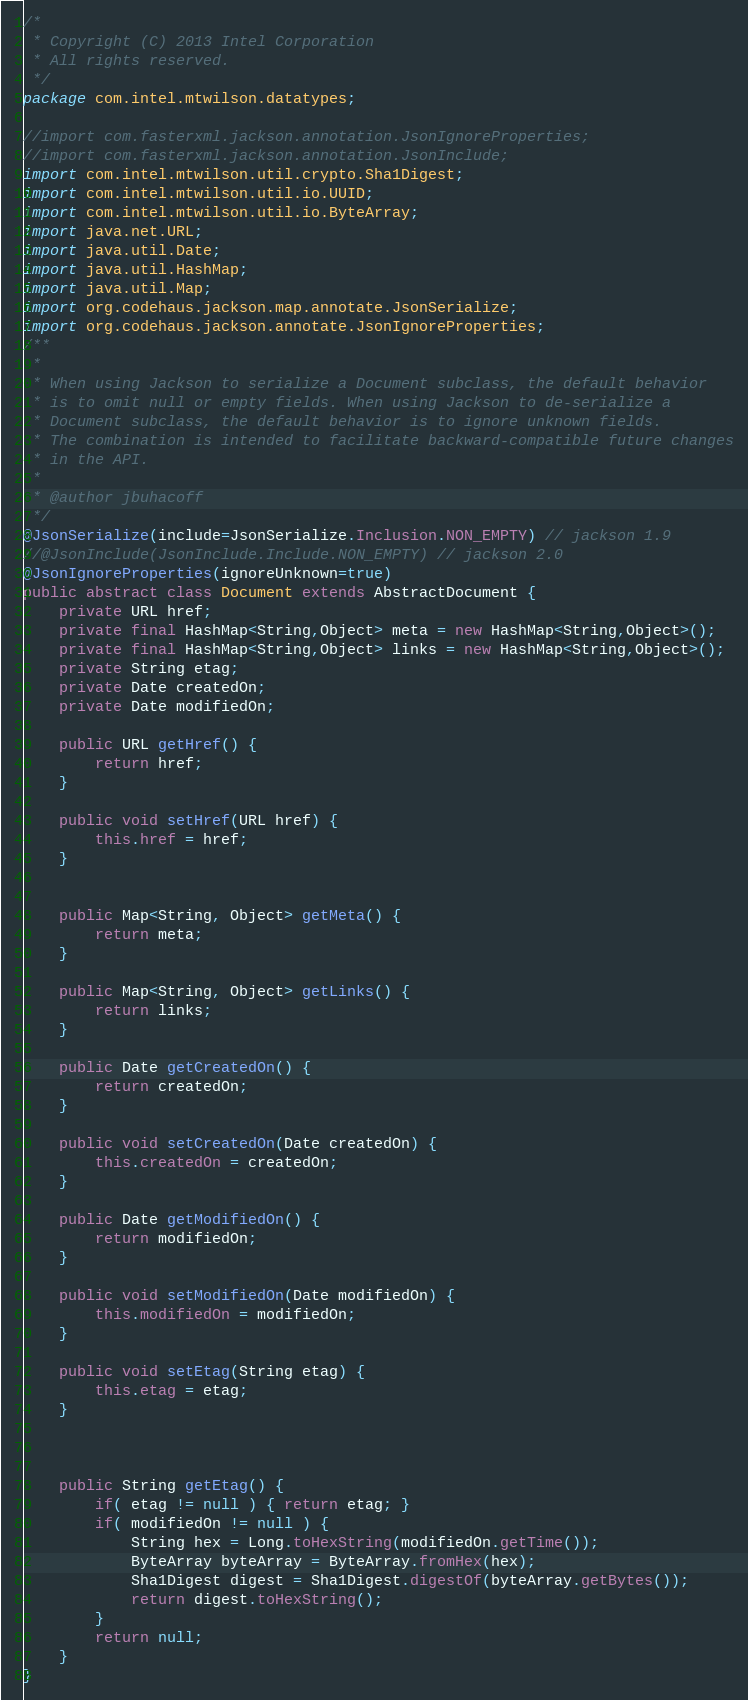Convert code to text. <code><loc_0><loc_0><loc_500><loc_500><_Java_>/*
 * Copyright (C) 2013 Intel Corporation
 * All rights reserved.
 */
package com.intel.mtwilson.datatypes;

//import com.fasterxml.jackson.annotation.JsonIgnoreProperties;
//import com.fasterxml.jackson.annotation.JsonInclude;
import com.intel.mtwilson.util.crypto.Sha1Digest;
import com.intel.mtwilson.util.io.UUID;
import com.intel.mtwilson.util.io.ByteArray;
import java.net.URL;
import java.util.Date;
import java.util.HashMap;
import java.util.Map;
import org.codehaus.jackson.map.annotate.JsonSerialize;
import org.codehaus.jackson.annotate.JsonIgnoreProperties;
/**
 *
 * When using Jackson to serialize a Document subclass, the default behavior
 * is to omit null or empty fields. When using Jackson to de-serialize a
 * Document subclass, the default behavior is to ignore unknown fields. 
 * The combination is intended to facilitate backward-compatible future changes
 * in the API.
 * 
 * @author jbuhacoff
 */
@JsonSerialize(include=JsonSerialize.Inclusion.NON_EMPTY) // jackson 1.9
//@JsonInclude(JsonInclude.Include.NON_EMPTY) // jackson 2.0
@JsonIgnoreProperties(ignoreUnknown=true)
public abstract class Document extends AbstractDocument {
    private URL href;
    private final HashMap<String,Object> meta = new HashMap<String,Object>();
    private final HashMap<String,Object> links = new HashMap<String,Object>();
    private String etag;
    private Date createdOn; 
    private Date modifiedOn;
    
    public URL getHref() {
        return href;
    }
    
    public void setHref(URL href) {
        this.href = href;
    }
    
    
    public Map<String, Object> getMeta() {
        return meta;
    }

    public Map<String, Object> getLinks() {
        return links;
    }

    public Date getCreatedOn() {
        return createdOn;
    }

    public void setCreatedOn(Date createdOn) {
        this.createdOn = createdOn;
    }

    public Date getModifiedOn() {
        return modifiedOn;
    }

    public void setModifiedOn(Date modifiedOn) {
        this.modifiedOn = modifiedOn;
    }

    public void setEtag(String etag) {
        this.etag = etag;
    }

    

    public String getEtag() {
        if( etag != null ) { return etag; }
        if( modifiedOn != null ) {
            String hex = Long.toHexString(modifiedOn.getTime());
            ByteArray byteArray = ByteArray.fromHex(hex);
            Sha1Digest digest = Sha1Digest.digestOf(byteArray.getBytes());
            return digest.toHexString();
        }
        return null;
    }
}
</code> 